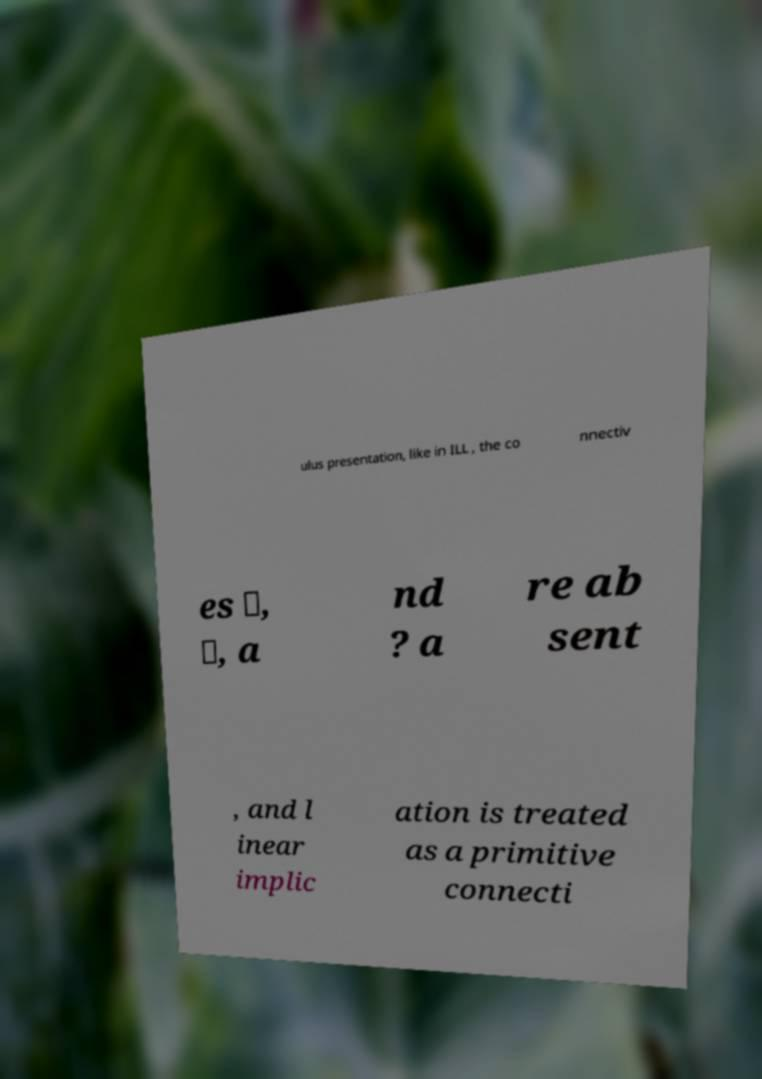Please read and relay the text visible in this image. What does it say? ulus presentation, like in ILL , the co nnectiv es ⅋, ⊥, a nd ? a re ab sent , and l inear implic ation is treated as a primitive connecti 